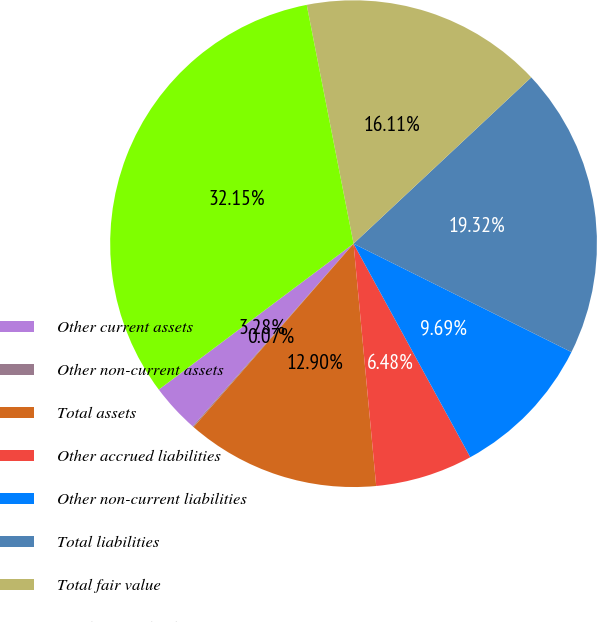Convert chart. <chart><loc_0><loc_0><loc_500><loc_500><pie_chart><fcel>Other current assets<fcel>Other non-current assets<fcel>Total assets<fcel>Other accrued liabilities<fcel>Other non-current liabilities<fcel>Total liabilities<fcel>Total fair value<fcel>Total notional value<nl><fcel>3.28%<fcel>0.07%<fcel>12.9%<fcel>6.48%<fcel>9.69%<fcel>19.32%<fcel>16.11%<fcel>32.15%<nl></chart> 